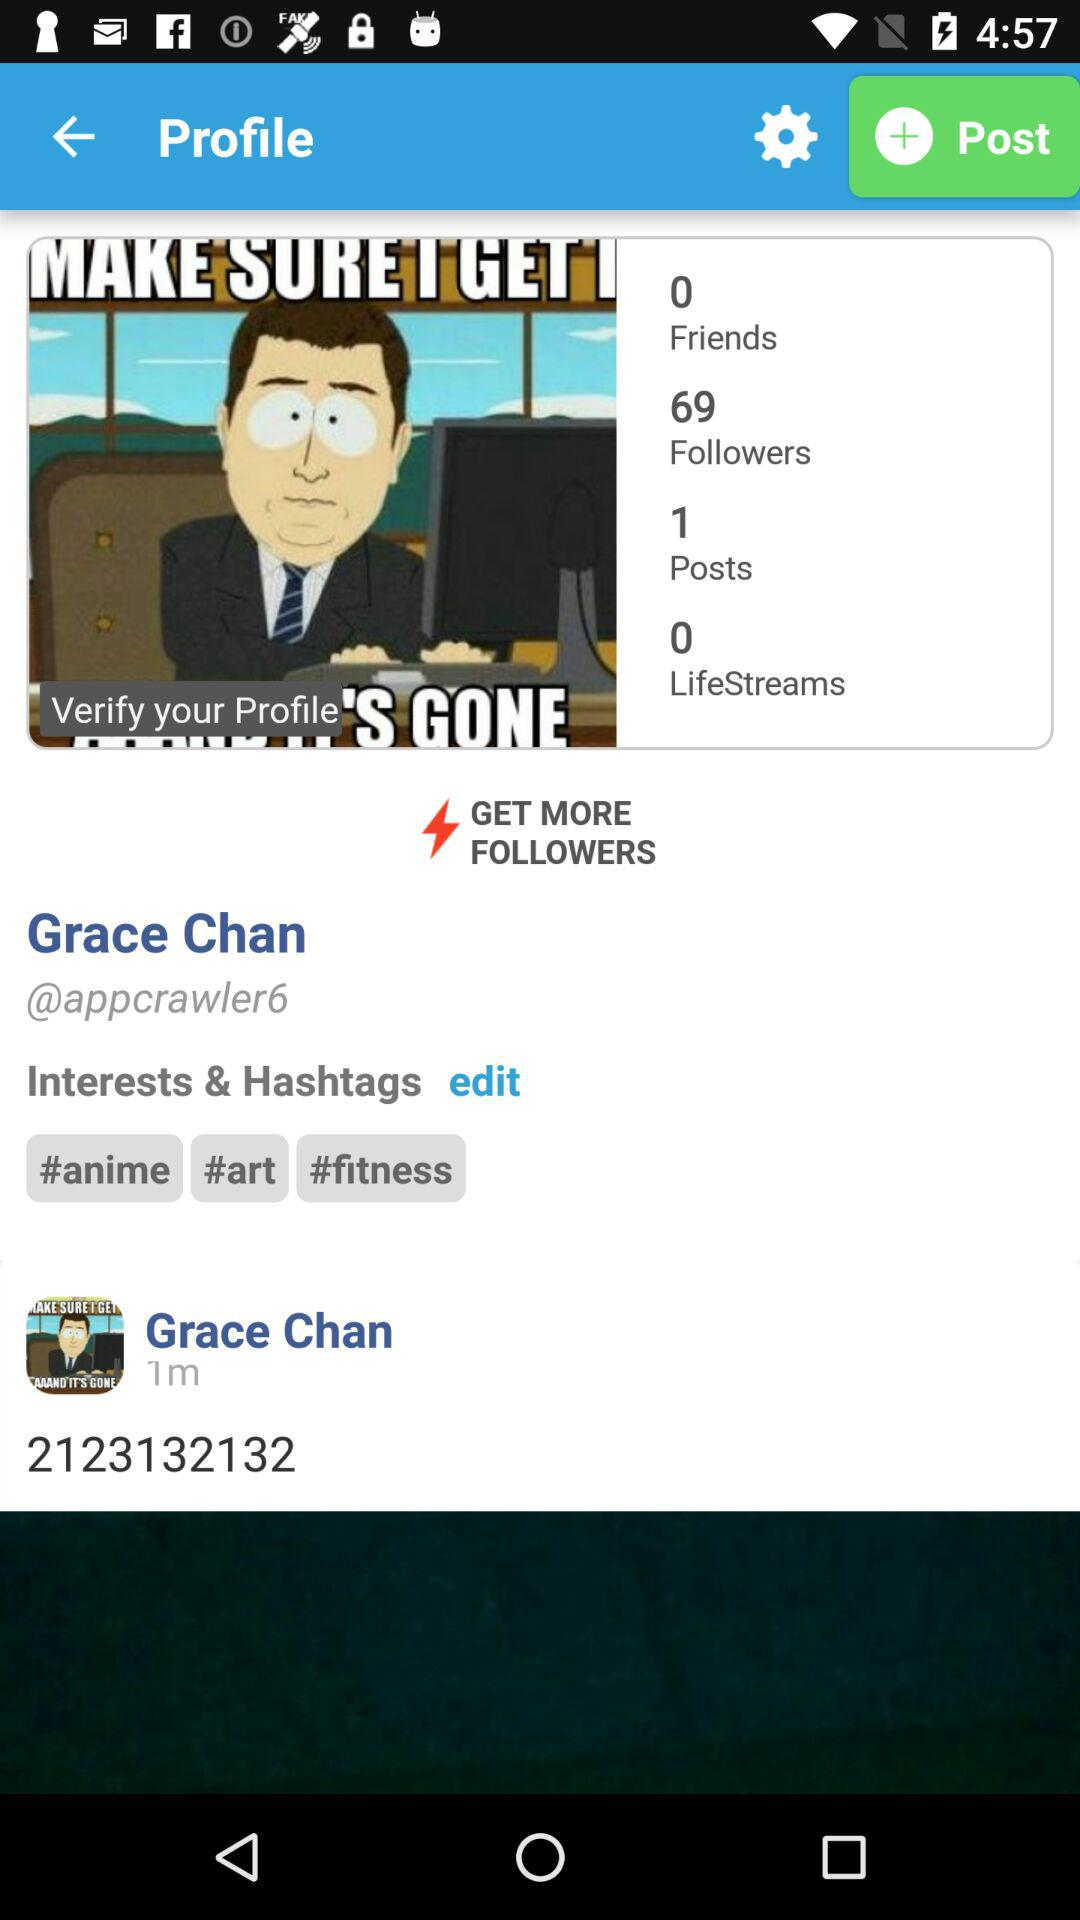How many more posts does Grace Chan have than lifestreams?
Answer the question using a single word or phrase. 1 